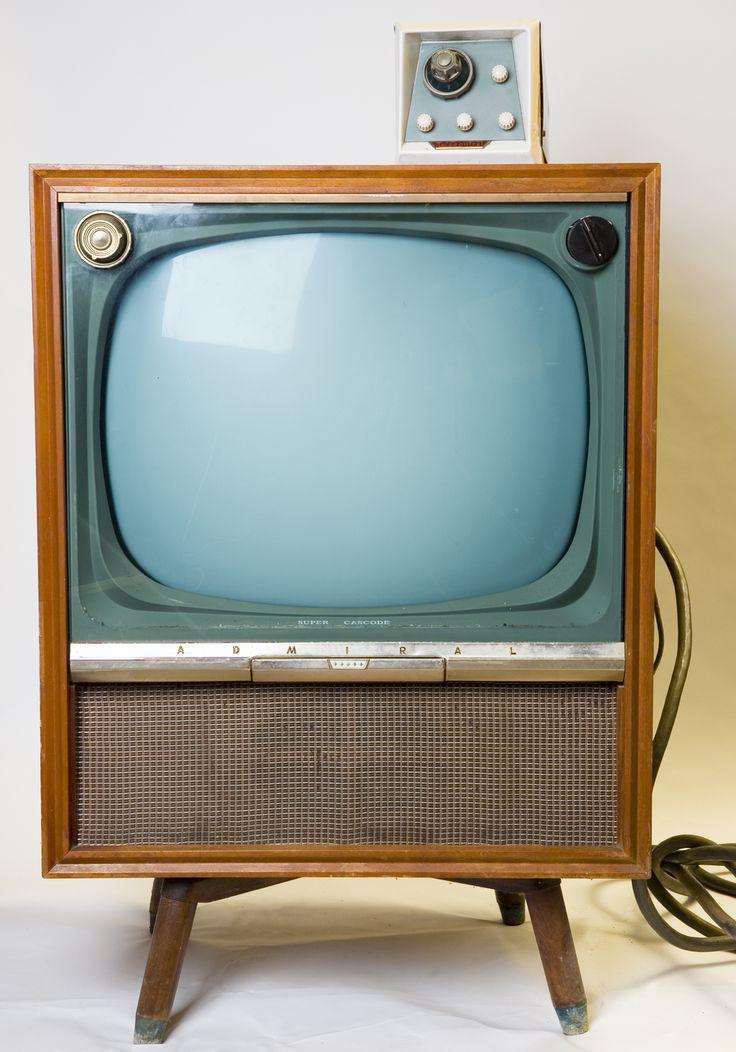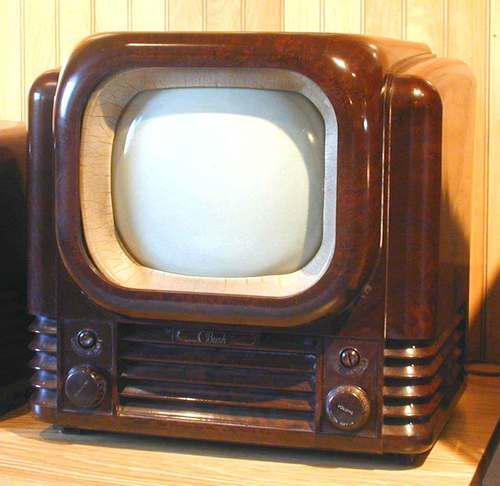The first image is the image on the left, the second image is the image on the right. Examine the images to the left and right. Is the description "In at least one image there is a small brown tv with a left and right knobs below the tv screen." accurate? Answer yes or no. Yes. The first image is the image on the left, the second image is the image on the right. Assess this claim about the two images: "One of the TVs has a screen with rounded corners inset in a light brown boxy console with legs.". Correct or not? Answer yes or no. Yes. 